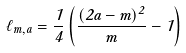Convert formula to latex. <formula><loc_0><loc_0><loc_500><loc_500>\ell _ { m , a } = \frac { 1 } { 4 } \left ( \frac { ( 2 a - m ) ^ { 2 } } { m } - 1 \right )</formula> 